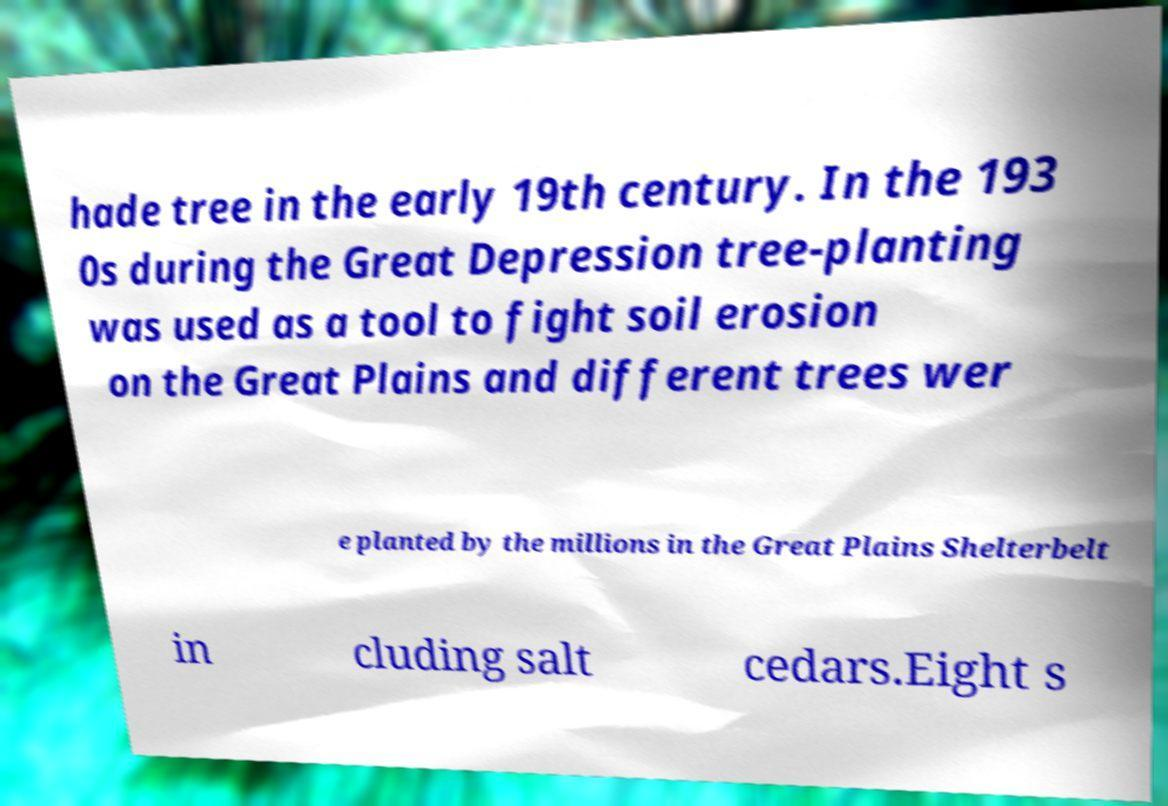What messages or text are displayed in this image? I need them in a readable, typed format. hade tree in the early 19th century. In the 193 0s during the Great Depression tree-planting was used as a tool to fight soil erosion on the Great Plains and different trees wer e planted by the millions in the Great Plains Shelterbelt in cluding salt cedars.Eight s 